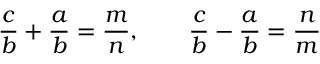Convert formula to latex. <formula><loc_0><loc_0><loc_500><loc_500>{ \frac { c } { b } } + { \frac { a } { b } } = { \frac { m } { n } } , \quad \frac { c } { b } - { \frac { a } { b } } = { \frac { n } { m } }</formula> 